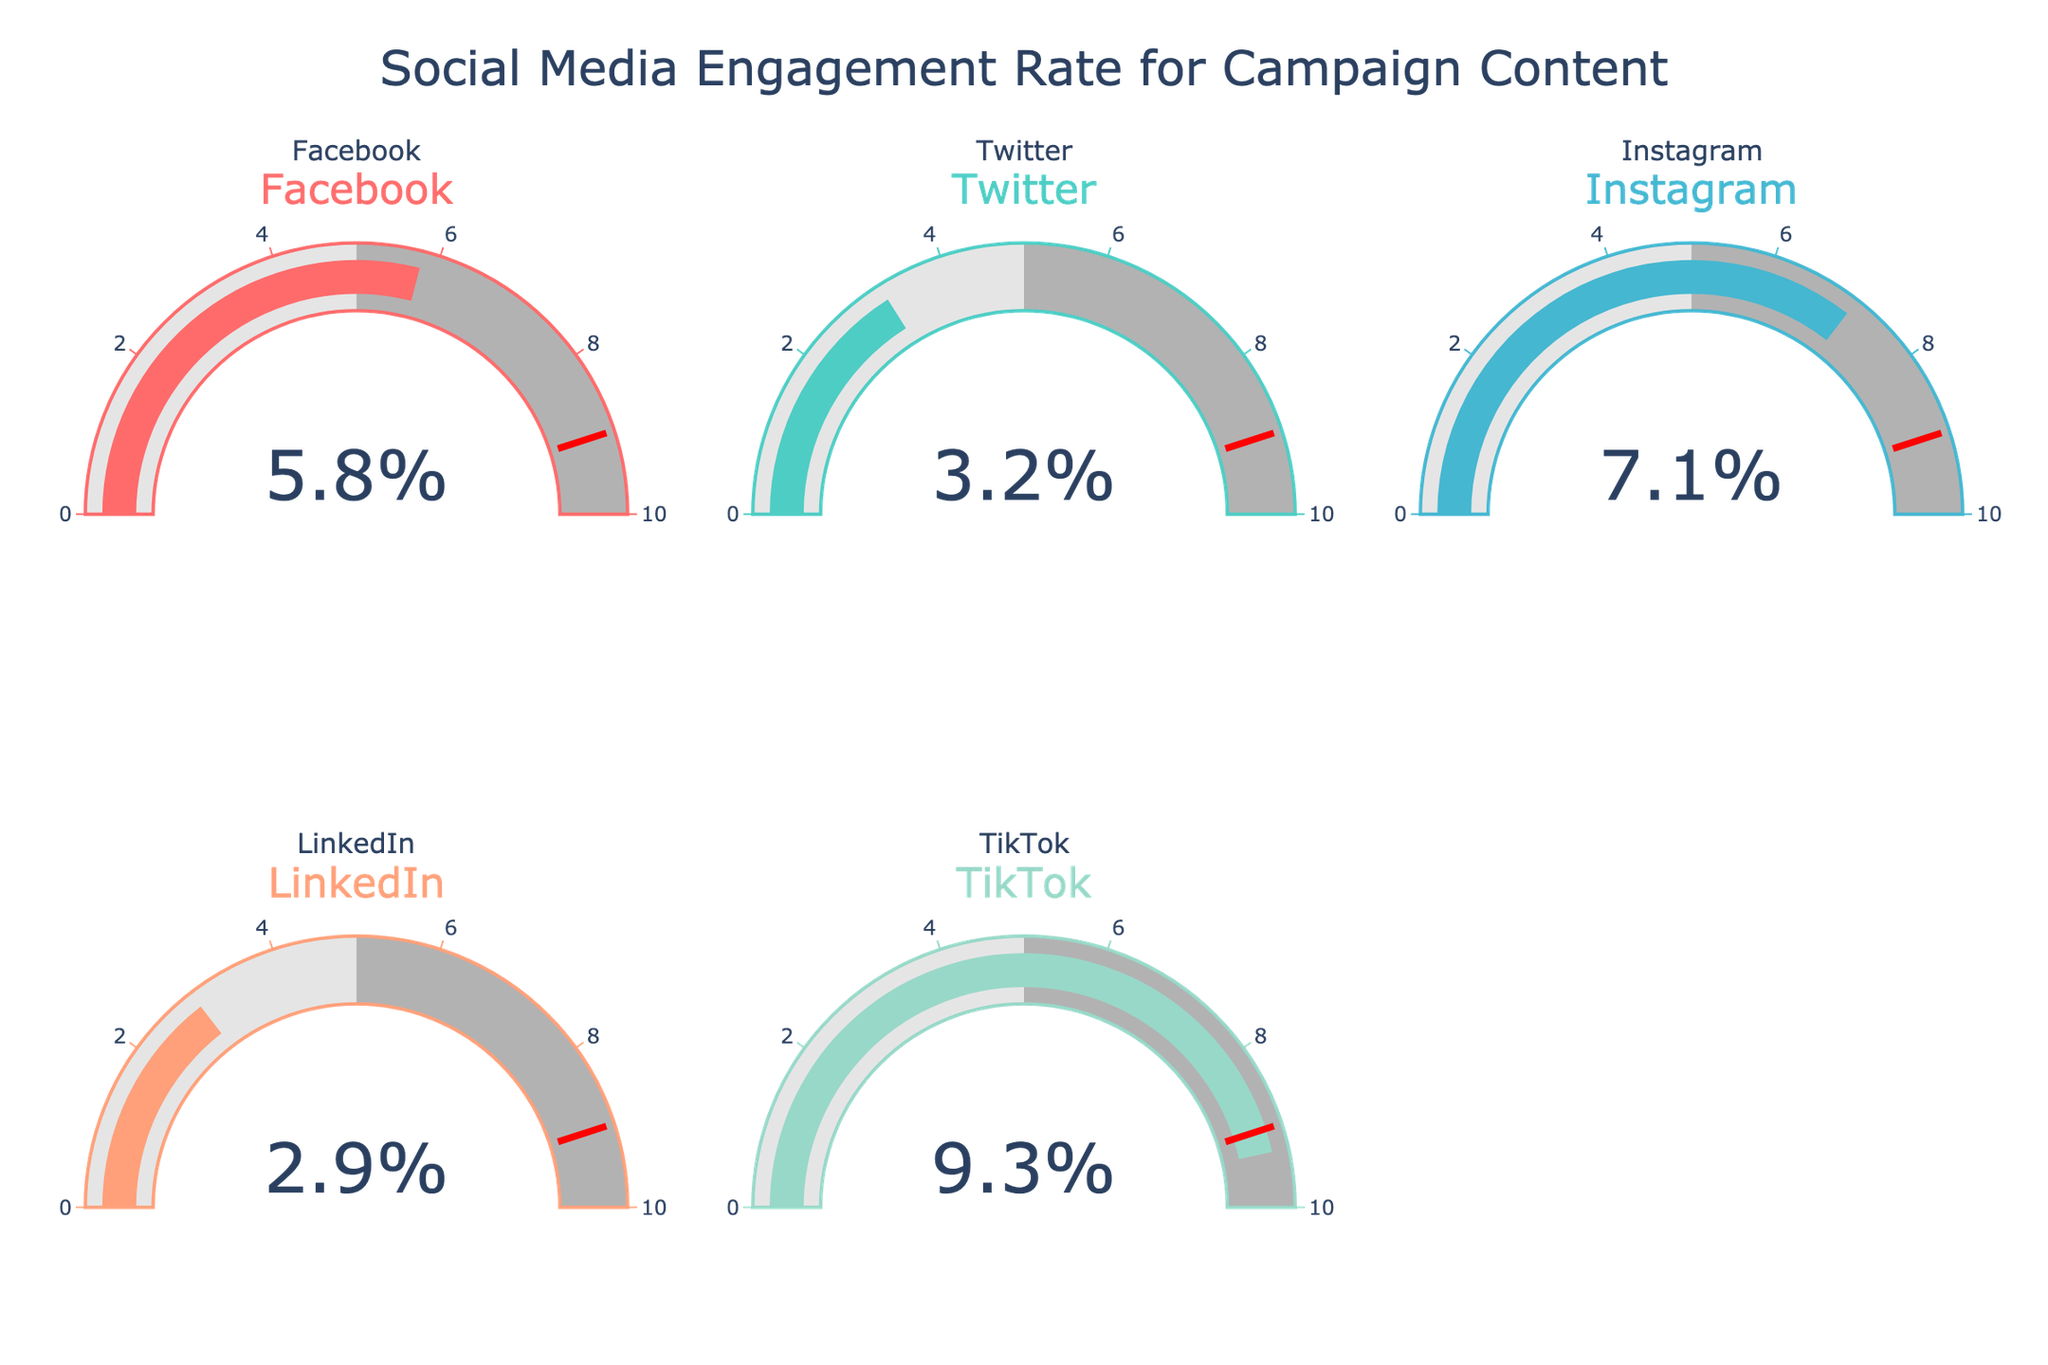What is the engagement rate for Facebook? The gauge for Facebook shows a value. We directly read the number from the gauge that represents Facebook.
Answer: 5.8 Which platform has the highest engagement rate? Compare the numbers displayed on each gauge. The highest number among the platforms is the engagement rate for TikTok.
Answer: TikTok What is the difference in engagement rates between Twitter and LinkedIn? Subtract the engagement rate of LinkedIn from that of Twitter. Engagement rate for Twitter is 3.2 and for LinkedIn is 2.9. Difference = 3.2 - 2.9
Answer: 0.3 Calculate the average engagement rate across all platforms. Sum all engagement rates and divide by the number of platforms. Rates: 5.8 + 3.2 + 7.1 + 2.9 + 9.3 = 28.3. Average = 28.3 / 5
Answer: 5.66 Between Instagram and Facebook, which platform has a higher engagement rate and by how much? Compare the values for Instagram and Facebook and subtract the smaller from the larger. Instagram: 7.1, Facebook: 5.8. Difference = 7.1 - 5.8
Answer: Instagram, 1.3 Is there any platform that has an engagement rate above the threshold specified in the gauge (9%)? Inspect each gauge to identify if any engagement rate exceeds the threshold mark (9%). Both TikTok and Instagram's rates meet or exceed this criterion.
Answer: TikTok What total number of platforms are represented in the gauge charts? Count the number of individual gauges, each representing a different platform. There are 5 gauges, hence 5 platforms.
Answer: 5 